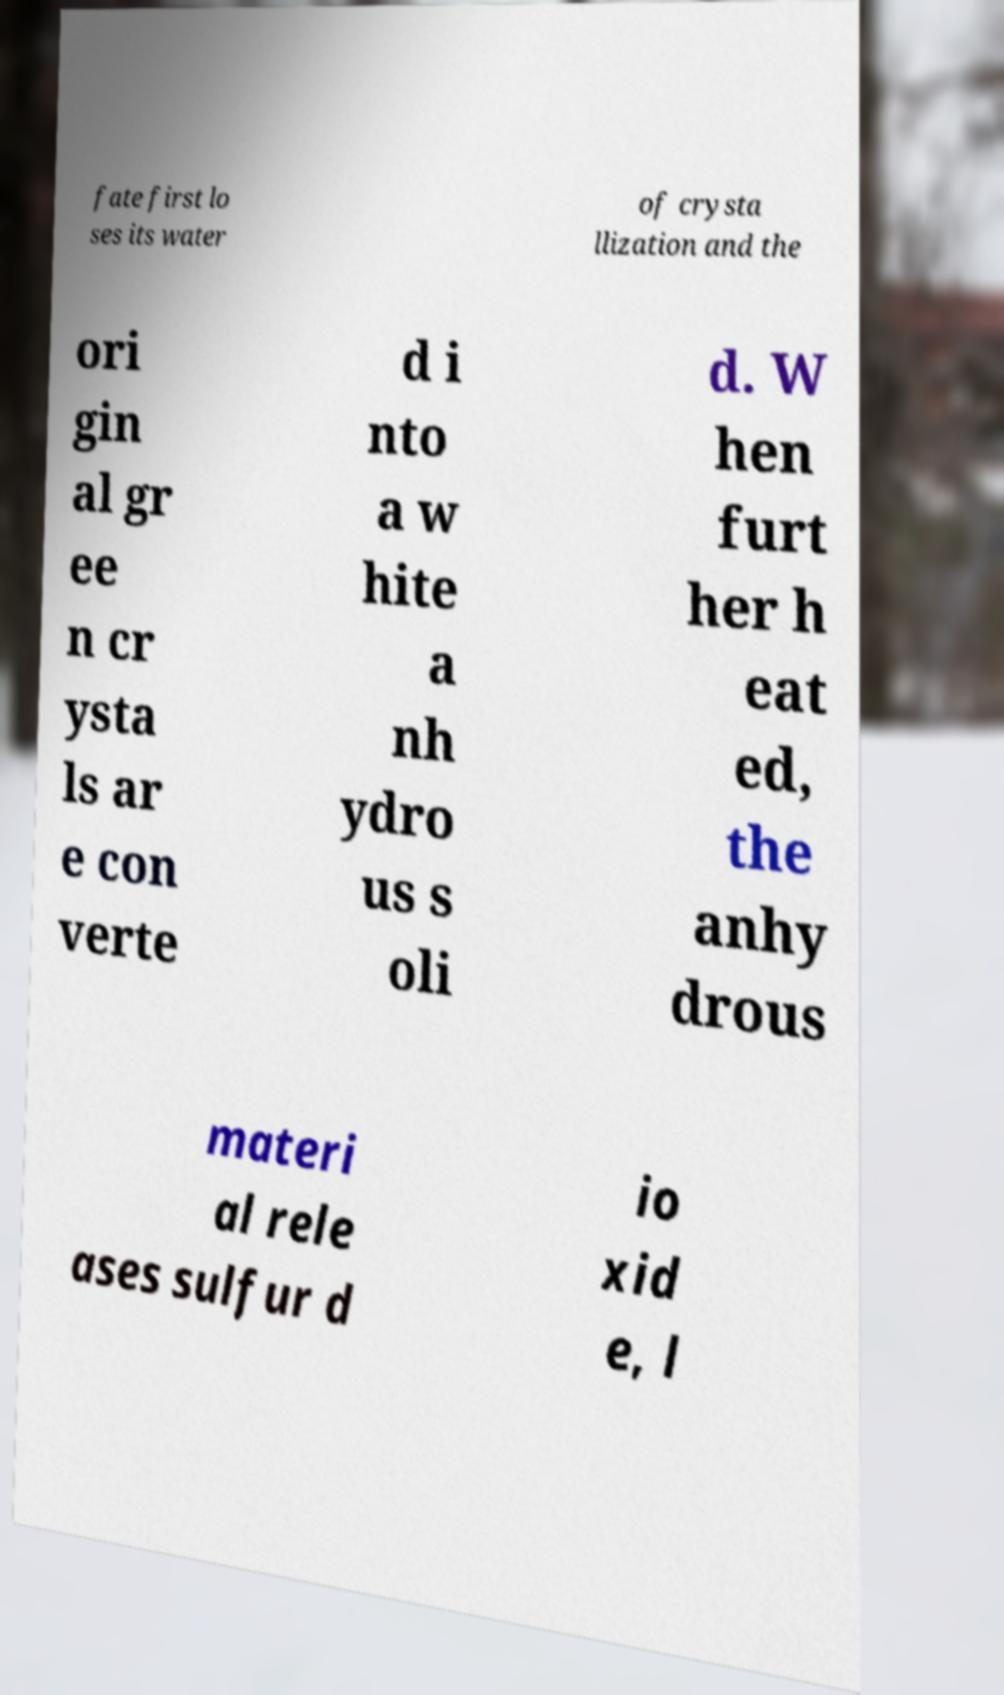What messages or text are displayed in this image? I need them in a readable, typed format. fate first lo ses its water of crysta llization and the ori gin al gr ee n cr ysta ls ar e con verte d i nto a w hite a nh ydro us s oli d. W hen furt her h eat ed, the anhy drous materi al rele ases sulfur d io xid e, l 